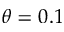Convert formula to latex. <formula><loc_0><loc_0><loc_500><loc_500>\theta = 0 . 1</formula> 